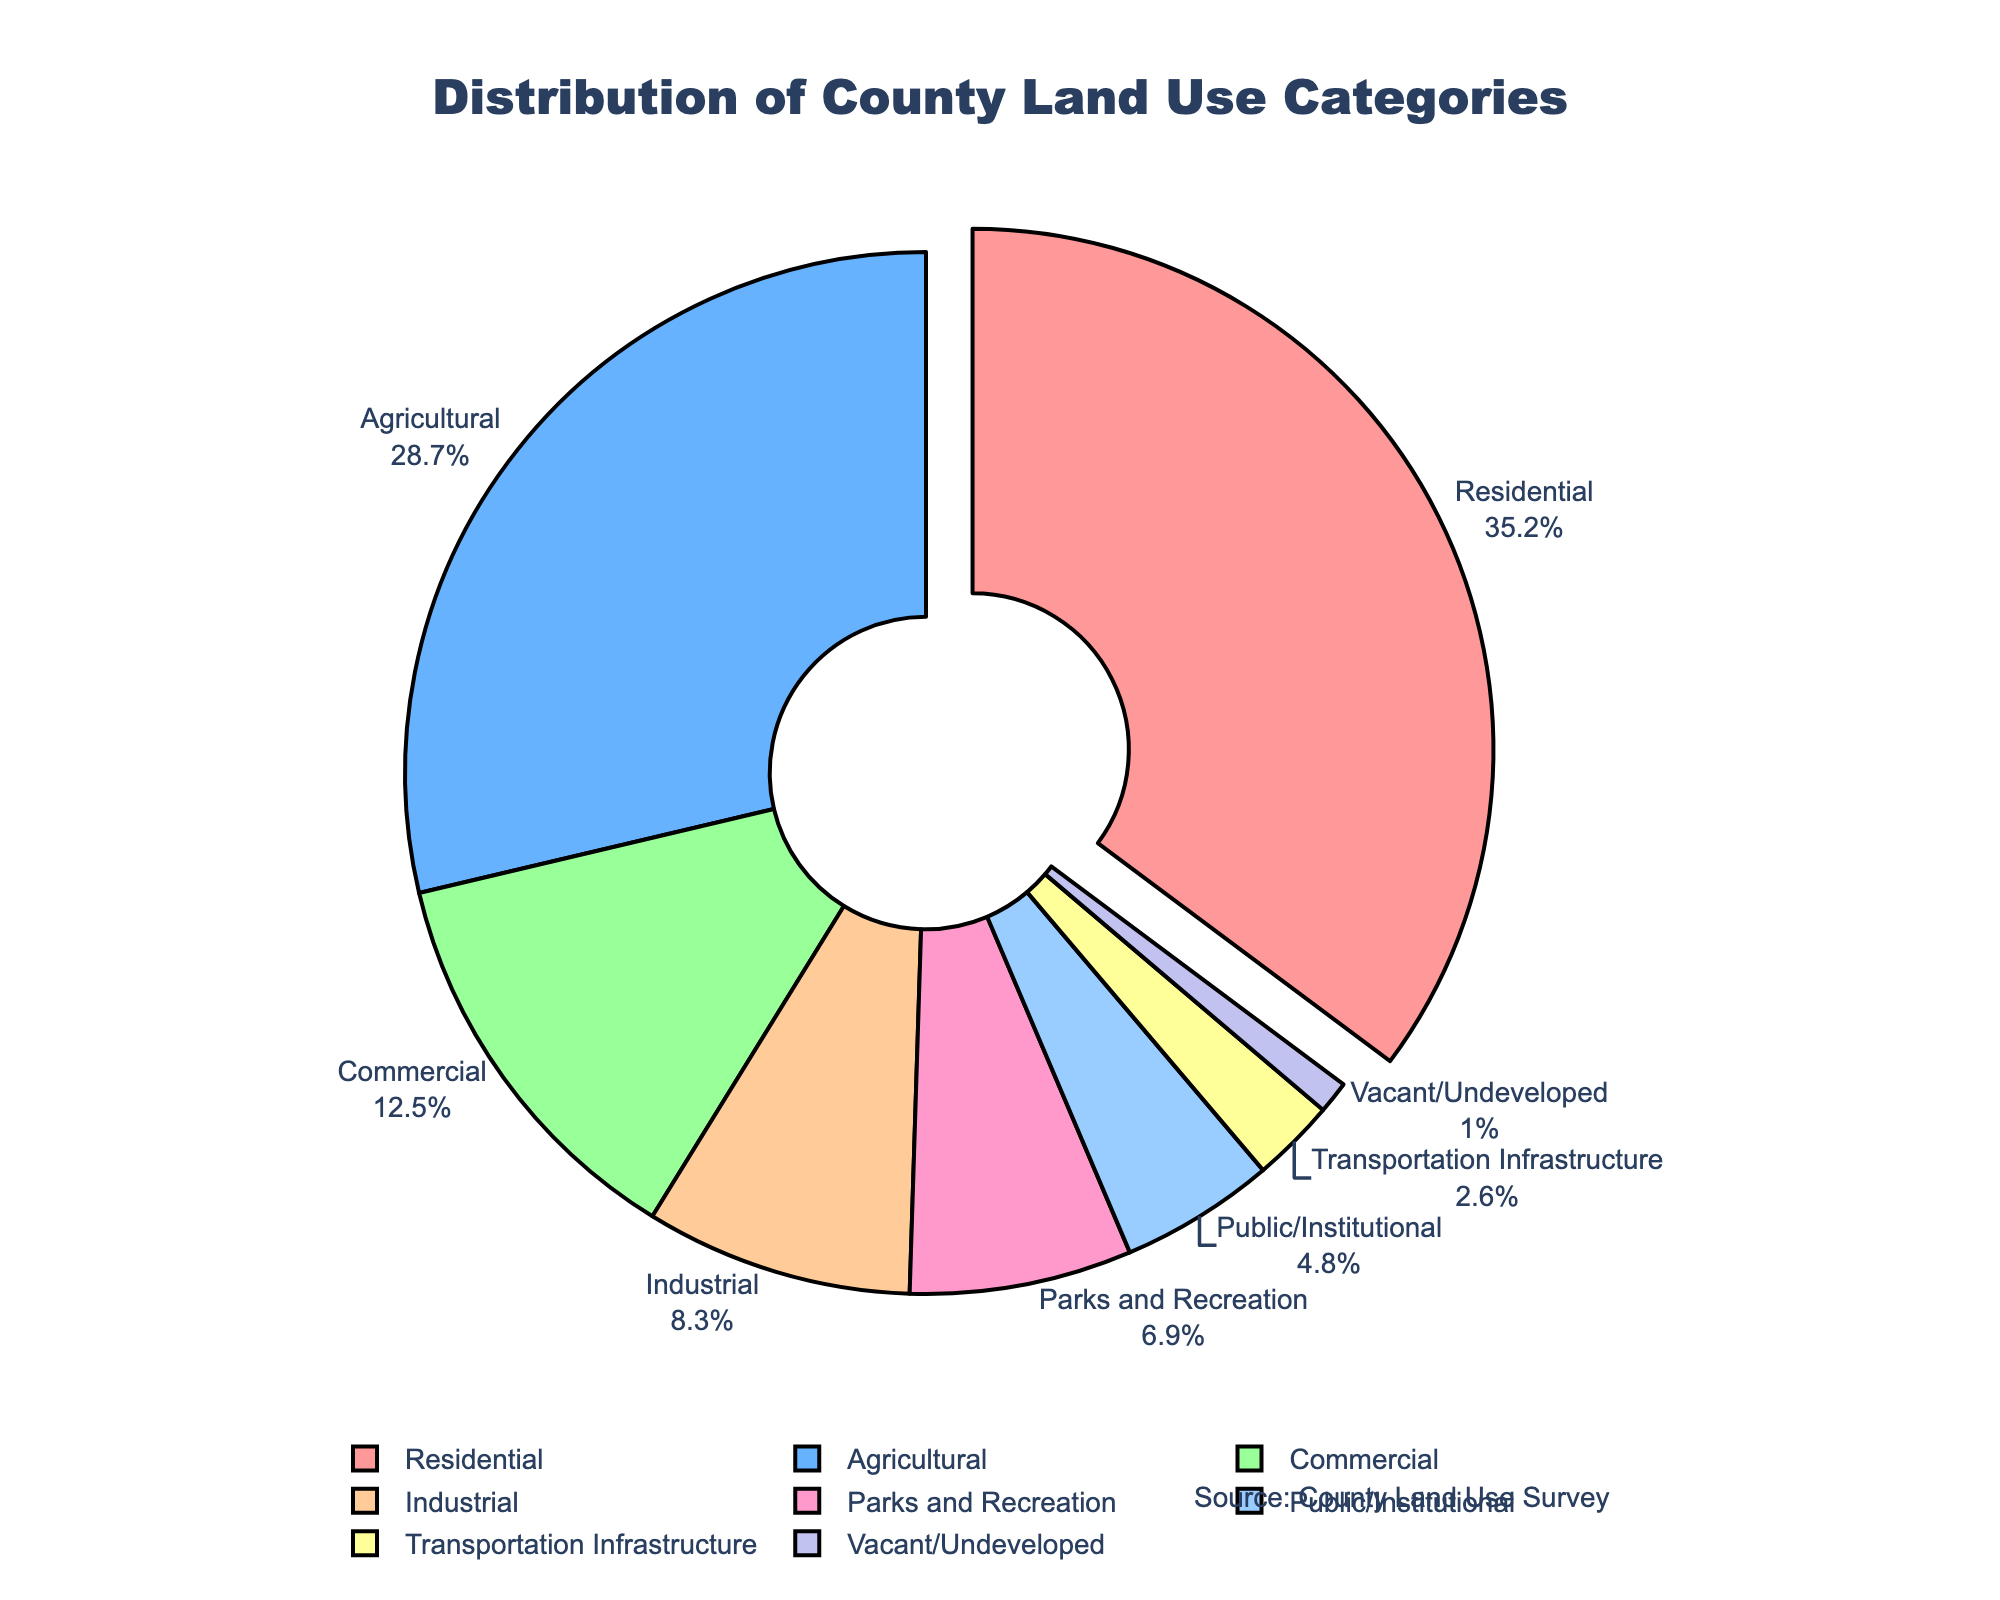What's the largest land use category in the county? The largest slice on the pie chart is labeled "Residential" which accounts for 35.2% of the land use.
Answer: Residential What's the smallest land use category in the county? The smallest slice on the pie chart is labeled "Vacant/Undeveloped" which accounts for 1.0% of the land use.
Answer: Vacant/Undeveloped Which two categories together make up more than half of the county's land use? Adding the percentages of the largest two categories: Residential (35.2%) and Agricultural (28.7%) gives us 35.2 + 28.7 = 63.9%, which is more than half.
Answer: Residential and Agricultural How does the area used for Parks and Recreation compare to the area used for Industrial purposes? Parks and Recreation accounts for 6.9% whereas Industrial accounts for 8.3%. Since 6.9% is less than 8.3%, Parks and Recreation uses less land than Industrial purposes.
Answer: Parks and Recreation is less than Industrial What is the combined percentage of land used for Public/Institutional and Transportation Infrastructure purposes? Public/Institutional accounts for 4.8% and Transportation Infrastructure accounts for 2.6%. Adding these two percentages gives 4.8 + 2.6 = 7.4%.
Answer: 7.4% Is the area designated for Commercial use greater than the combined area for Parks and Recreation and Public/Institutional use? Commercial use accounts for 12.5%, while Parks and Recreation combined with Public/Institutional use accounts for 6.9 + 4.8 = 11.7%. Since 12.5% is greater than 11.7%, the Commercial use area is greater.
Answer: Yes What's the percentage difference between the land used for Residential and Agricultural purposes? Residential accounts for 35.2% and Agricultural accounts for 28.7%. The difference is 35.2 - 28.7 = 6.5%.
Answer: 6.5% If Transportation Infrastructure and Vacant/Undeveloped land were combined, would it make up more area than Parks and Recreation? Transportation Infrastructure and Vacant/Undeveloped together account for 2.6 + 1.0 = 3.6%, which is less than Parks and Recreation's 6.9%.
Answer: No Which category has a larger area, Industrial or Commercial? The Commercial category accounts for 12.5% and the Industrial category accounts for 8.3%. Since 12.5% is greater than 8.3%, Commercial has a larger area.
Answer: Commercial 